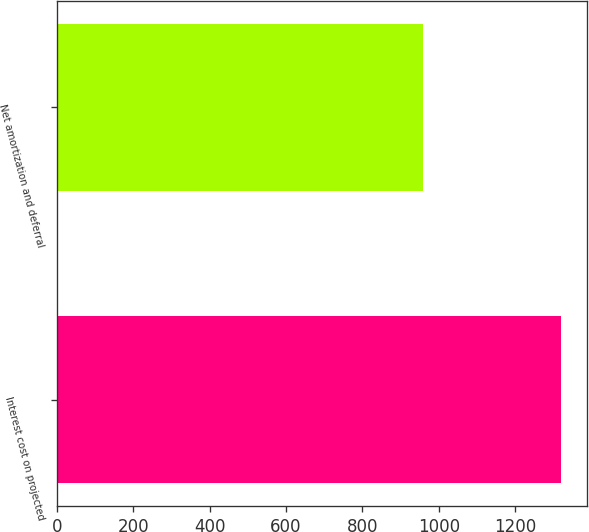Convert chart to OTSL. <chart><loc_0><loc_0><loc_500><loc_500><bar_chart><fcel>Interest cost on projected<fcel>Net amortization and deferral<nl><fcel>1321<fcel>958<nl></chart> 